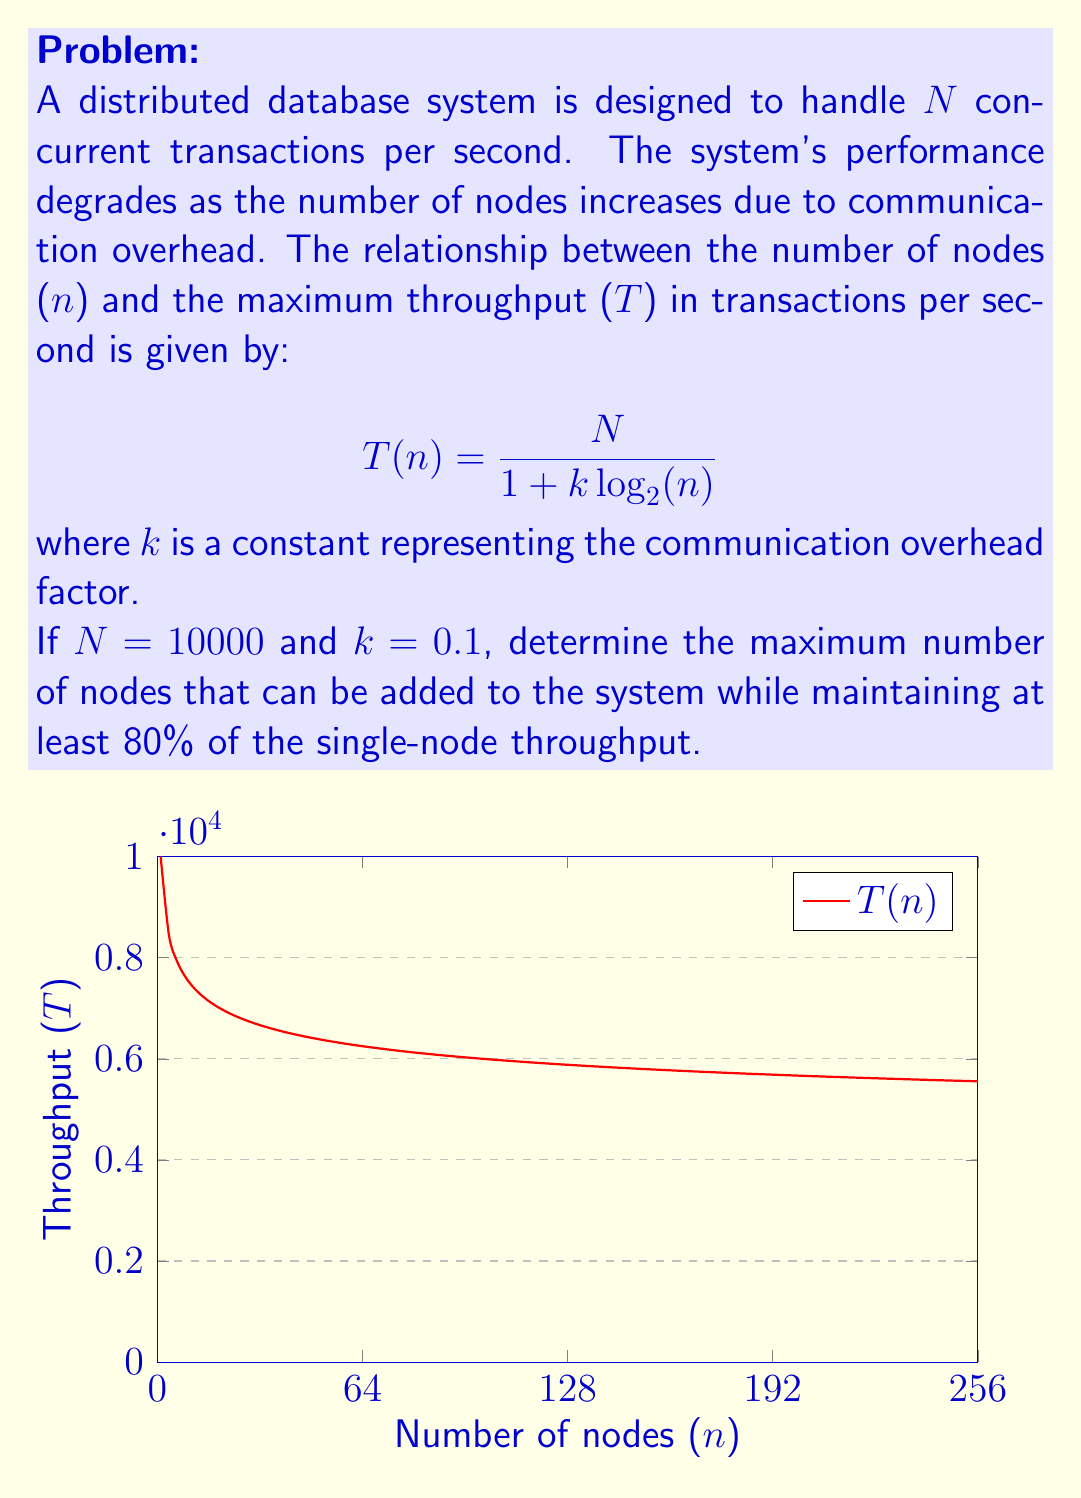Provide a solution to this math problem. To solve this problem, we'll follow these steps:

1) First, let's calculate the single-node throughput:
   $$T(1) = \frac{10000}{1 + 0.1\log_2(1)} = \frac{10000}{1 + 0} = 10000$$

2) We want to maintain at least 80% of this throughput, so our target is:
   $$0.8 \times 10000 = 8000$$

3) Now, we need to solve the equation:
   $$\frac{10000}{1 + 0.1\log_2(n)} = 8000$$

4) Let's solve this step by step:
   $$\frac{10000}{8000} = 1 + 0.1\log_2(n)$$
   $$1.25 = 1 + 0.1\log_2(n)$$
   $$0.25 = 0.1\log_2(n)$$
   $$2.5 = \log_2(n)$$
   $$2^{2.5} = n$$

5) Calculate the final result:
   $$n = 2^{2.5} \approx 5.66$$

6) Since we're looking for the maximum number of nodes, we round down to the nearest integer.
Answer: 5 nodes 